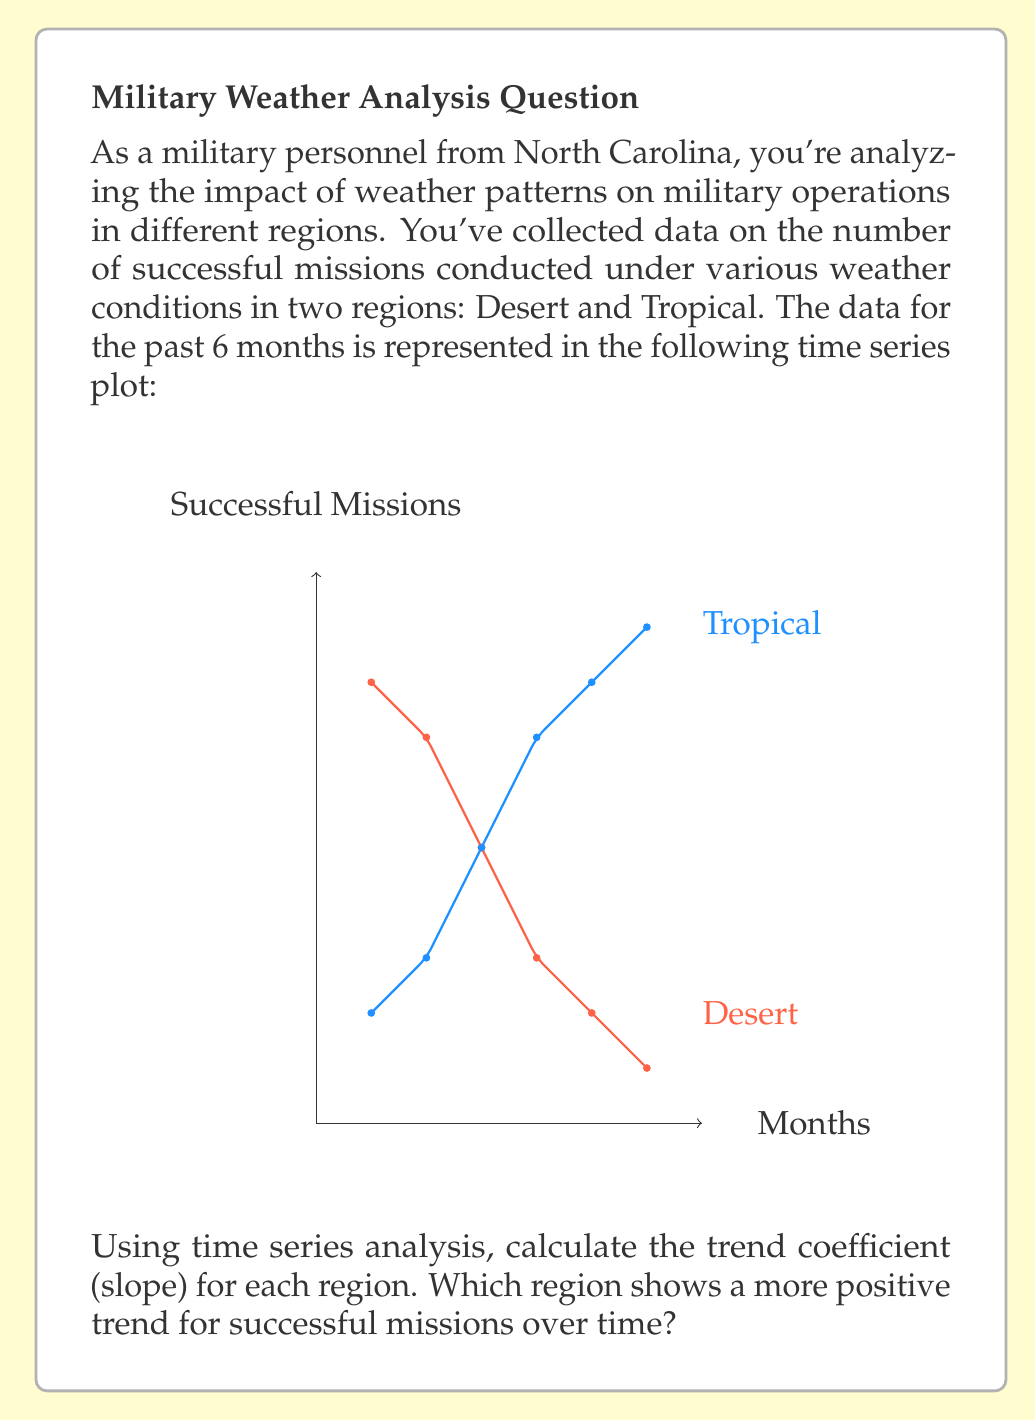Teach me how to tackle this problem. To solve this problem, we'll use the least squares method to calculate the trend coefficient (slope) for each region. The trend coefficient will indicate how the number of successful missions is changing over time.

Step 1: Set up the equations for the trend line.
The trend line equation is $y = mx + b$, where $m$ is the slope (trend coefficient) and $b$ is the y-intercept.

Step 2: Calculate the slope using the formula:
$$m = \frac{n\sum xy - \sum x \sum y}{n\sum x^2 - (\sum x)^2}$$

Where:
$n$ = number of data points
$x$ = time (months)
$y$ = number of successful missions

Step 3: Calculate for Desert region
$\sum x = 1 + 2 + 3 + 4 + 5 + 6 = 21$
$\sum y = 8 + 7 + 5 + 3 + 2 + 1 = 26$
$\sum xy = 1(8) + 2(7) + 3(5) + 4(3) + 5(2) + 6(1) = 70$
$\sum x^2 = 1^2 + 2^2 + 3^2 + 4^2 + 5^2 + 6^2 = 91$

$$m_{Desert} = \frac{6(70) - 21(26)}{6(91) - 21^2} = \frac{420 - 546}{546 - 441} = \frac{-126}{105} = -1.2$$

Step 4: Calculate for Tropical region
$\sum x = 21$ (same as Desert)
$\sum y = 2 + 3 + 5 + 7 + 8 + 9 = 34$
$\sum xy = 1(2) + 2(3) + 3(5) + 4(7) + 5(8) + 6(9) = 132$
$\sum x^2 = 91$ (same as Desert)

$$m_{Tropical} = \frac{6(132) - 21(34)}{6(91) - 21^2} = \frac{792 - 714}{546 - 441} = \frac{78}{105} \approx 0.74$$

Step 5: Compare the trend coefficients
Desert region: $m_{Desert} = -1.2$
Tropical region: $m_{Tropical} \approx 0.74$

The Tropical region has a positive trend coefficient, while the Desert region has a negative trend coefficient.
Answer: Tropical region (slope ≈ 0.74) 